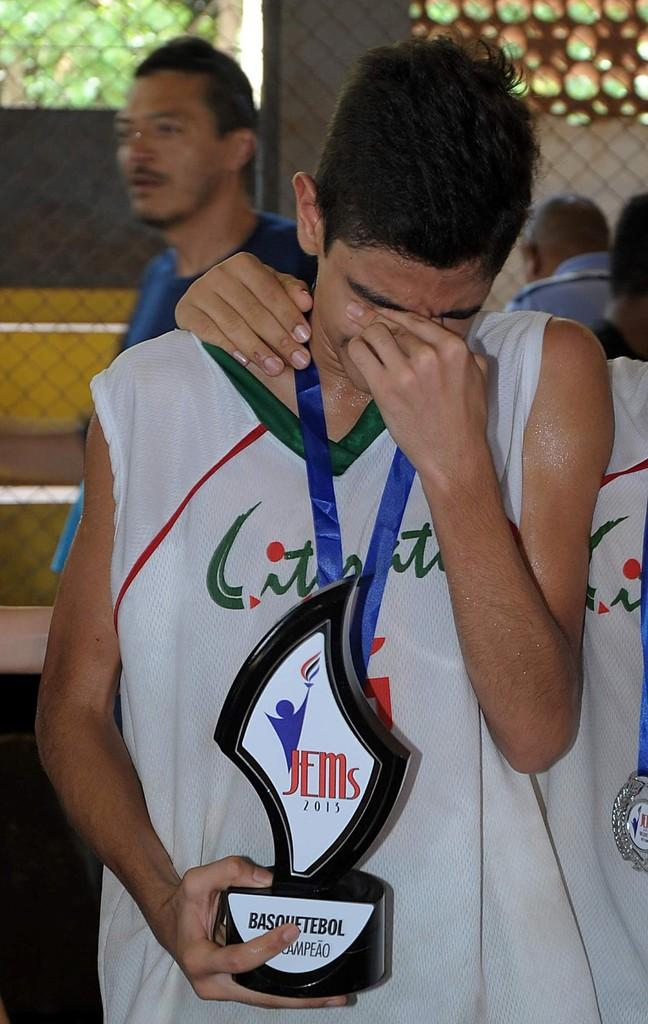<image>
Present a compact description of the photo's key features. A man with his hand over his face holding a trophy reading Jems. 